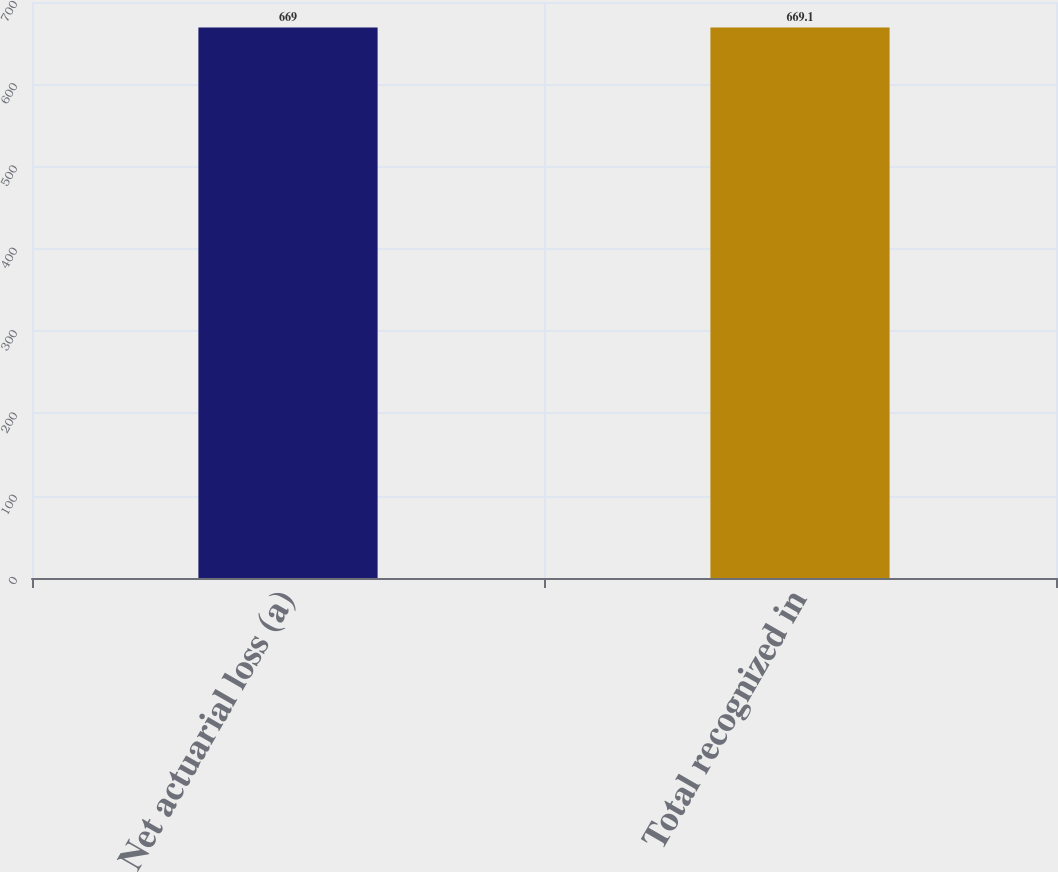Convert chart to OTSL. <chart><loc_0><loc_0><loc_500><loc_500><bar_chart><fcel>Net actuarial loss (a)<fcel>Total recognized in<nl><fcel>669<fcel>669.1<nl></chart> 